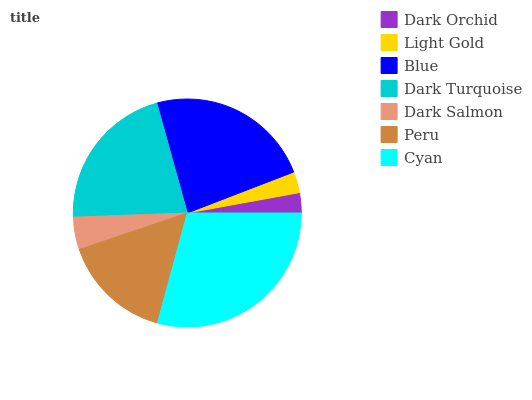Is Dark Orchid the minimum?
Answer yes or no. Yes. Is Cyan the maximum?
Answer yes or no. Yes. Is Light Gold the minimum?
Answer yes or no. No. Is Light Gold the maximum?
Answer yes or no. No. Is Light Gold greater than Dark Orchid?
Answer yes or no. Yes. Is Dark Orchid less than Light Gold?
Answer yes or no. Yes. Is Dark Orchid greater than Light Gold?
Answer yes or no. No. Is Light Gold less than Dark Orchid?
Answer yes or no. No. Is Peru the high median?
Answer yes or no. Yes. Is Peru the low median?
Answer yes or no. Yes. Is Blue the high median?
Answer yes or no. No. Is Light Gold the low median?
Answer yes or no. No. 